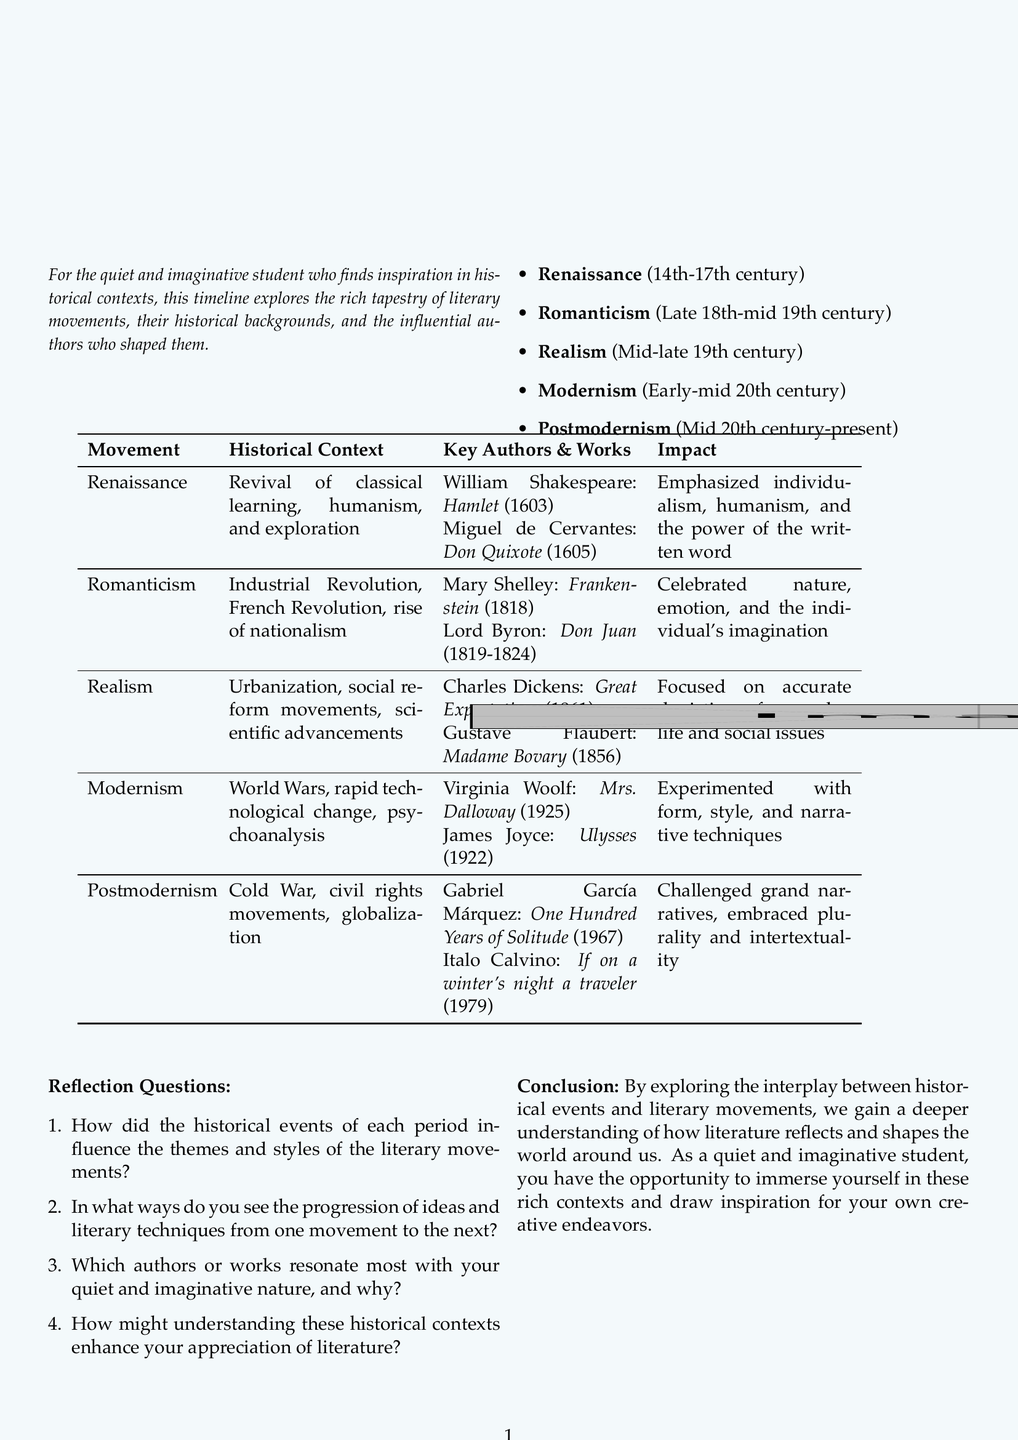What is the title of the brochure? The title is presented prominently at the top of the document.
Answer: A Journey Through Literary History: Movements, Contexts, and Masterpieces Which literary movement is associated with the years 14th-17th century? The document lists each movement along with its corresponding time period.
Answer: Renaissance Who wrote "Frankenstein"? The document includes names of key authors alongside their influential works.
Answer: Mary Shelley What was a significant historical context of the Modernism movement? This information is provided alongside each literary movement to show their backgrounds.
Answer: World Wars Name one key work of Gabriel García Márquez. The document specifies key authors and their works for each literary movement.
Answer: One Hundred Years of Solitude What impact did the Realism movement focus on? Each movement includes a description of its impact on literature.
Answer: Accurate depiction of everyday life and social issues How many reflection questions are provided in the brochure? The document lists the reflection questions numerically, which helps determine their count.
Answer: Four Which literary movement celebrated nature and emotion? The movements are linked with their distinctive themes and focuses in the document.
Answer: Romanticism Who is the author of "Ulysses"? This information is included as part of the key authors in the Modernism section.
Answer: James Joyce 